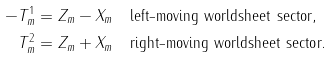<formula> <loc_0><loc_0><loc_500><loc_500>- T ^ { 1 } _ { m } & = Z _ { m } - X _ { m } \quad \text {left-moving worldsheet sector,} \\ T ^ { 2 } _ { m } & = Z _ { m } + X _ { m } \quad \text {right-moving worldsheet sector.}</formula> 